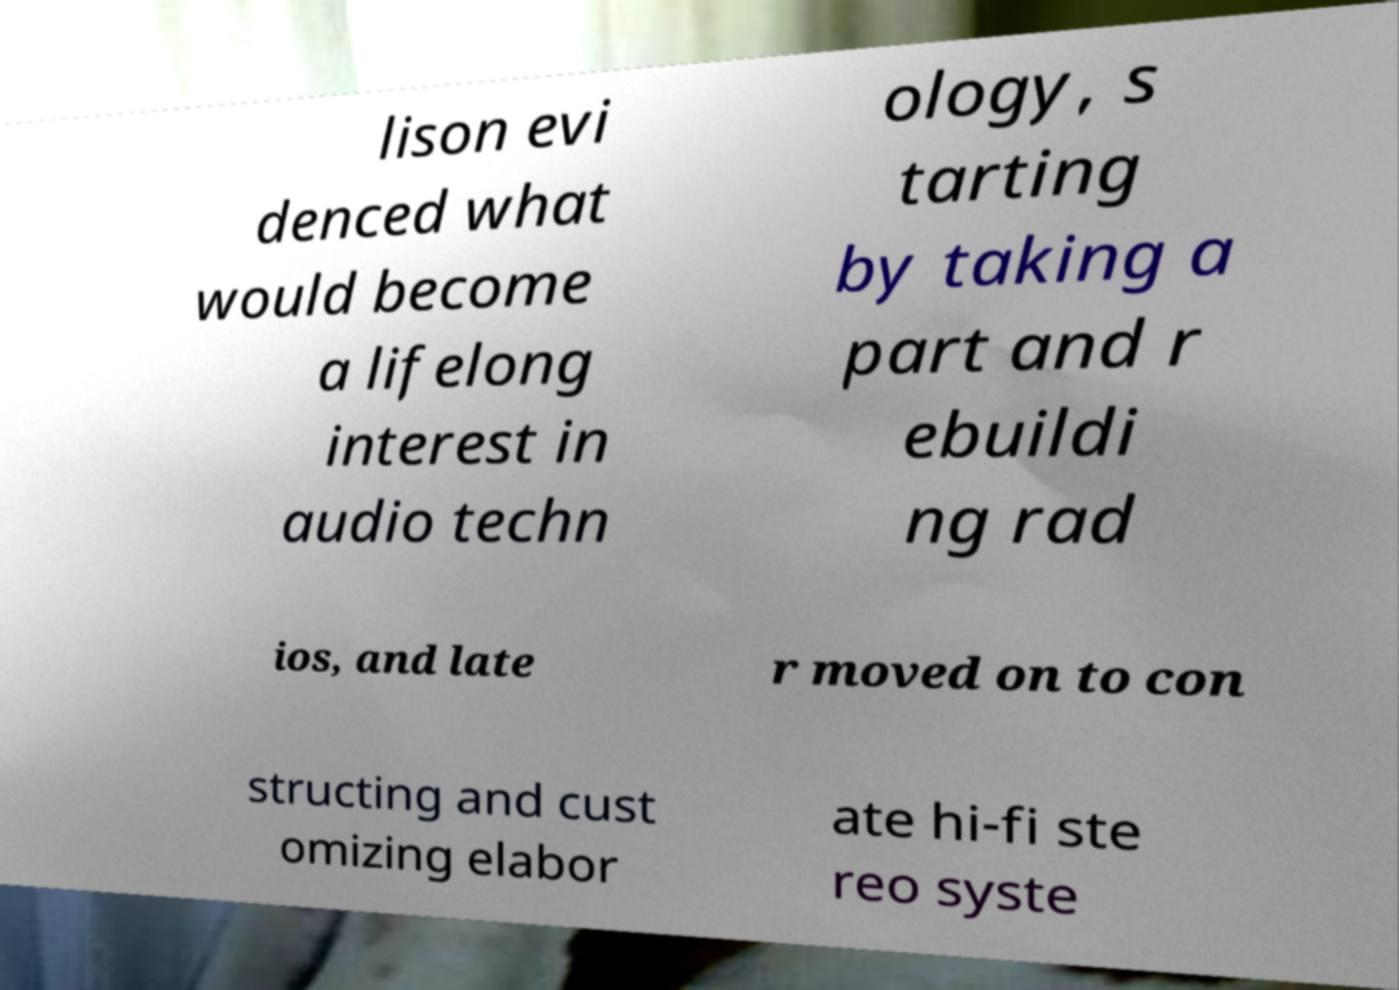Please read and relay the text visible in this image. What does it say? lison evi denced what would become a lifelong interest in audio techn ology, s tarting by taking a part and r ebuildi ng rad ios, and late r moved on to con structing and cust omizing elabor ate hi-fi ste reo syste 